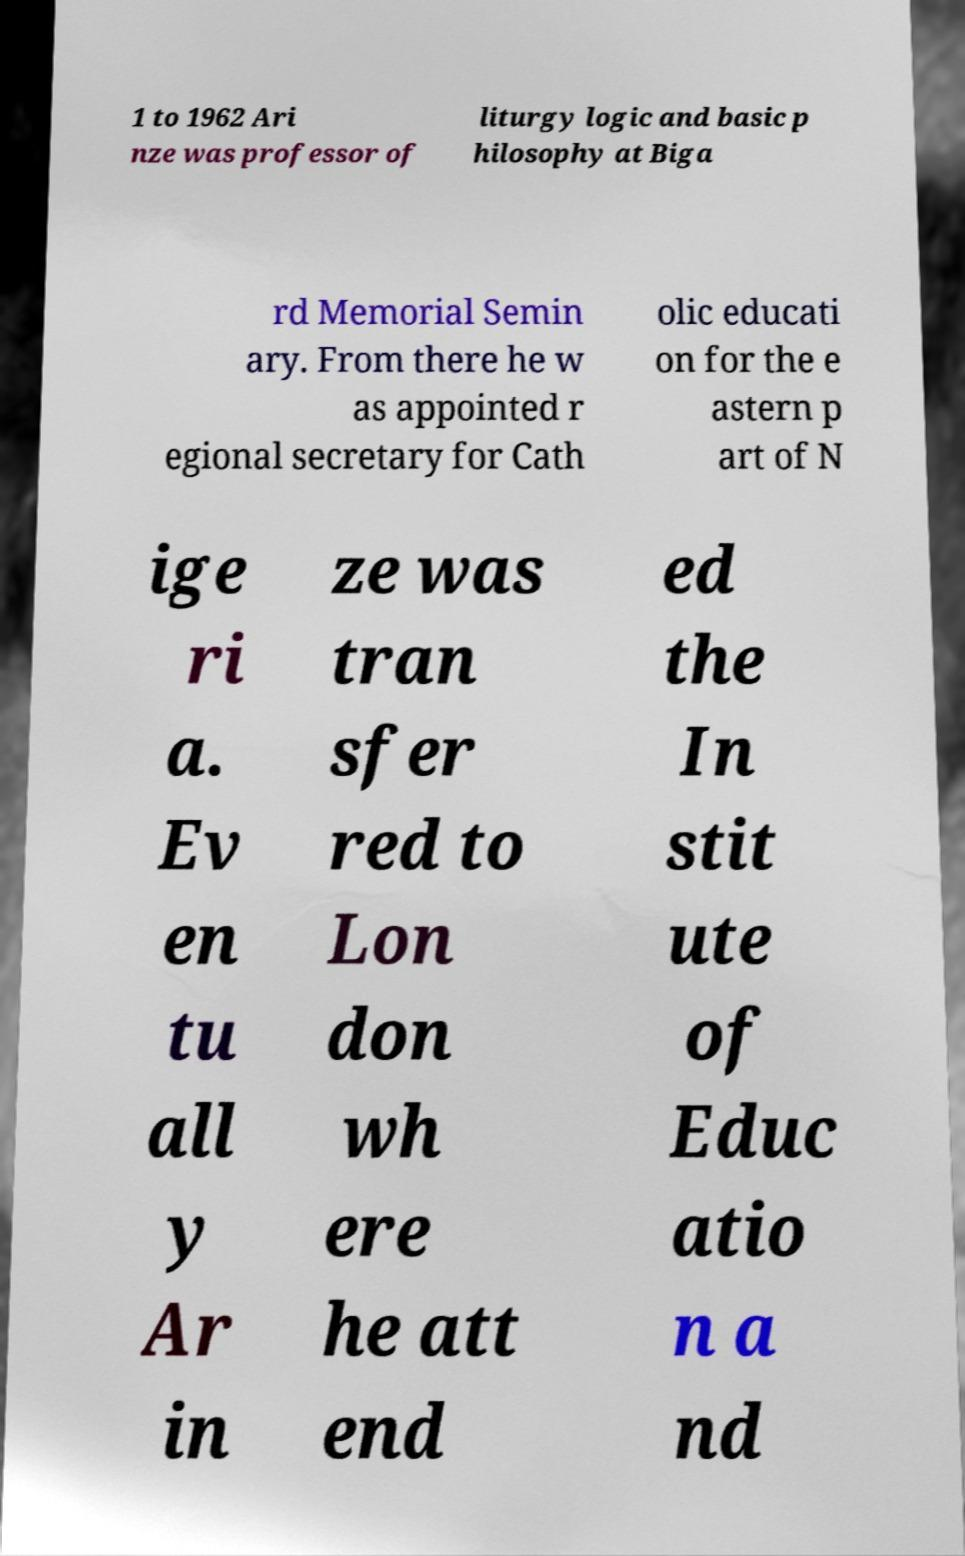Can you read and provide the text displayed in the image?This photo seems to have some interesting text. Can you extract and type it out for me? 1 to 1962 Ari nze was professor of liturgy logic and basic p hilosophy at Biga rd Memorial Semin ary. From there he w as appointed r egional secretary for Cath olic educati on for the e astern p art of N ige ri a. Ev en tu all y Ar in ze was tran sfer red to Lon don wh ere he att end ed the In stit ute of Educ atio n a nd 